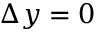Convert formula to latex. <formula><loc_0><loc_0><loc_500><loc_500>\Delta y = 0</formula> 